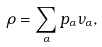Convert formula to latex. <formula><loc_0><loc_0><loc_500><loc_500>\rho = \sum _ { \alpha } p _ { \alpha } \nu _ { \alpha } ,</formula> 